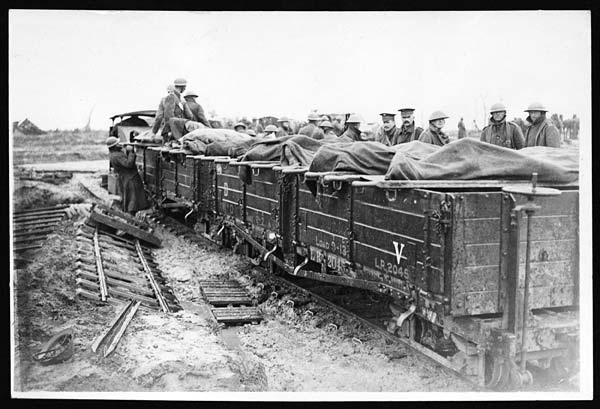Describe the objects in this image and their specific colors. I can see train in black, gray, darkgray, and lightgray tones, people in black, gray, darkgray, and lightgray tones, people in black, gray, darkgray, and lightgray tones, people in black, gray, darkgray, and lightgray tones, and people in black, darkgray, gray, and lightgray tones in this image. 